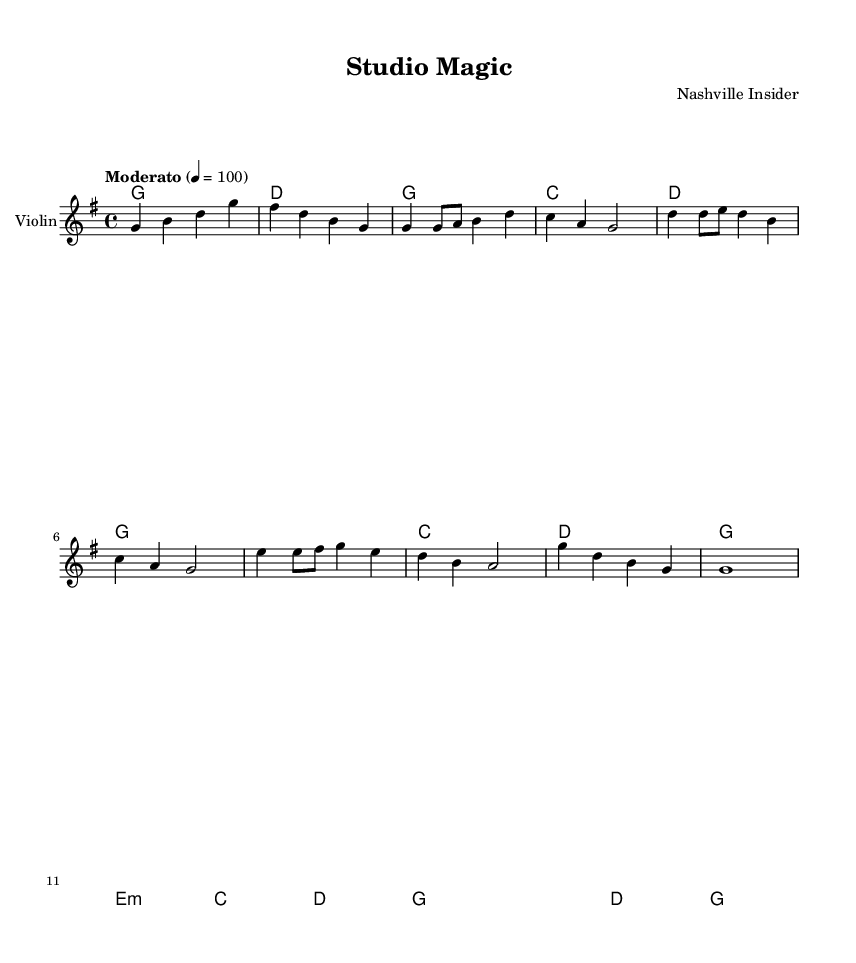What is the key signature of this music? The key signature is G major, which has one sharp (F#) and is indicated at the beginning of the staff.
Answer: G major What is the time signature of this piece? The time signature is 4/4, which is shown at the beginning of the score. It indicates there are four beats per measure.
Answer: 4/4 What is the tempo marking for this music? The tempo marking is "Moderato" at a speed of quarter note equals 100, as noted at the start of the score.
Answer: Moderato 100 How many measures are in the verse section? The verse section consists of four measures, which can be counted by analyzing the number of measure lines in that section of the music.
Answer: 4 Which chords are used in the chorus? The chorus features the chords G, C, and D, as outlined in the chord mode section of the score.
Answer: G, C, D What musical technique is highlighted in the lyrics "Pro -- du -- cers work -- ing through the night"? The technique here refers to a narrative lyrical style typical in country music, which tells a story; this reflects how the lyrics are crafted to evoke imagery relevant to the studio environment.
Answer: Narrative storytelling What is the overall structure of the music? The overall structure follows a common format in popular music, consisting of an intro, verse, chorus, bridge, and outro, as outlined in the various sections of the piece.
Answer: Intro, verse, chorus, bridge, outro 